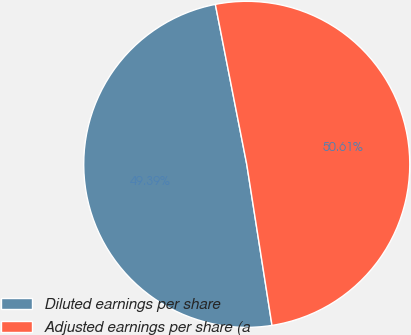Convert chart to OTSL. <chart><loc_0><loc_0><loc_500><loc_500><pie_chart><fcel>Diluted earnings per share<fcel>Adjusted earnings per share (a<nl><fcel>49.39%<fcel>50.61%<nl></chart> 